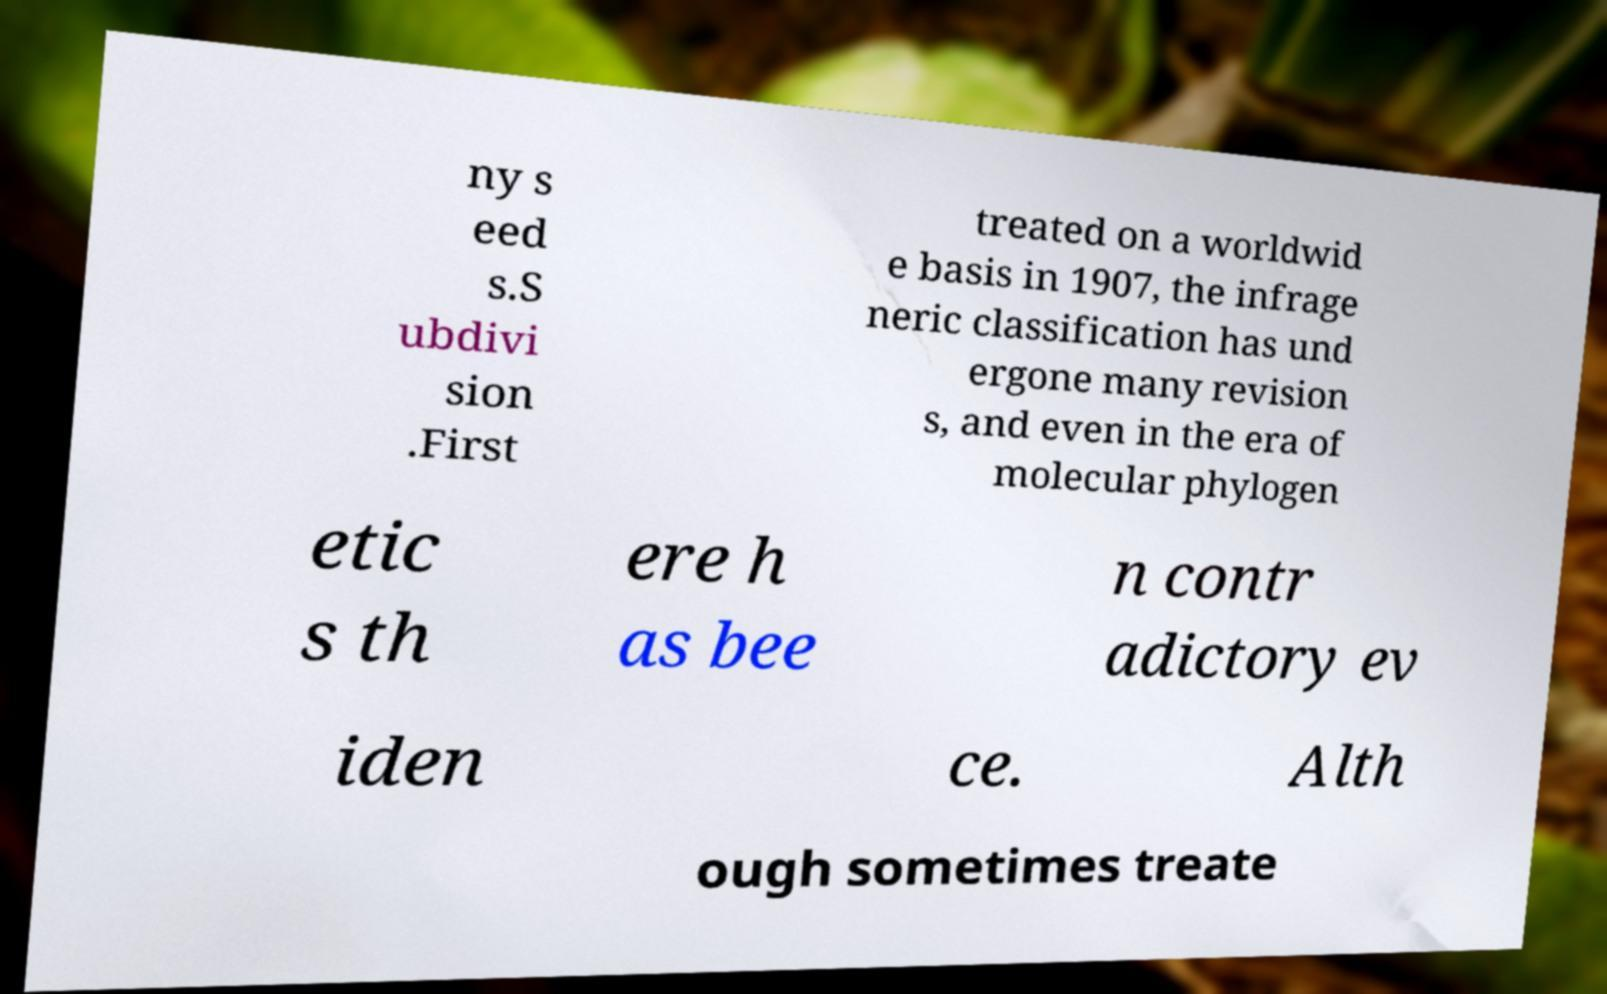For documentation purposes, I need the text within this image transcribed. Could you provide that? ny s eed s.S ubdivi sion .First treated on a worldwid e basis in 1907, the infrage neric classification has und ergone many revision s, and even in the era of molecular phylogen etic s th ere h as bee n contr adictory ev iden ce. Alth ough sometimes treate 